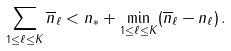<formula> <loc_0><loc_0><loc_500><loc_500>\sum _ { 1 \leq \ell \leq K } \overline { n } _ { \ell } < n _ { * } + \min _ { 1 \leq \ell \leq K } ( \overline { n } _ { \ell } - n _ { \ell } ) \, .</formula> 